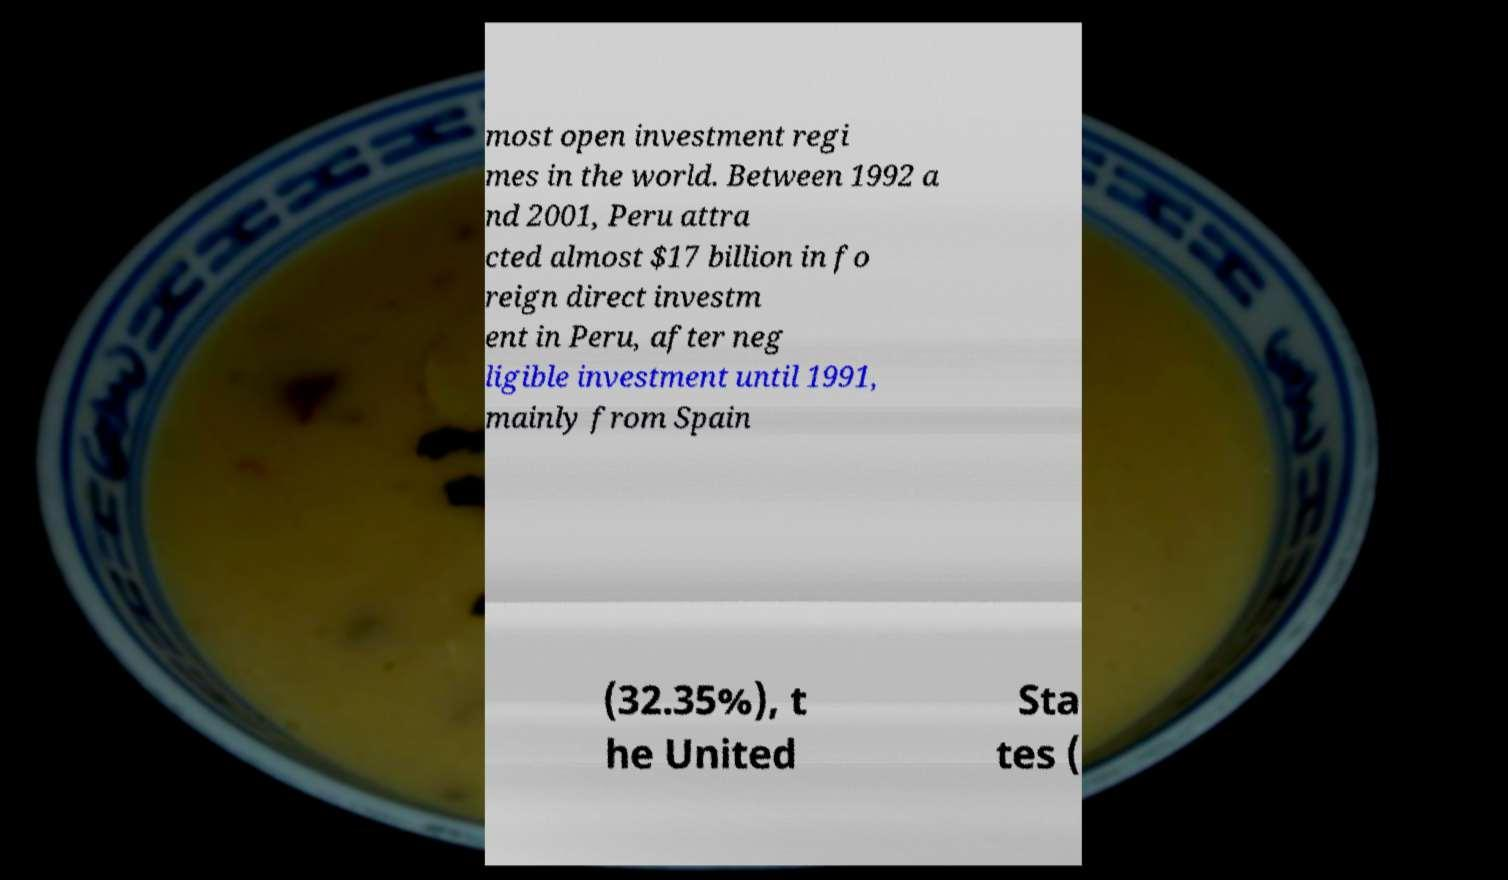Could you extract and type out the text from this image? most open investment regi mes in the world. Between 1992 a nd 2001, Peru attra cted almost $17 billion in fo reign direct investm ent in Peru, after neg ligible investment until 1991, mainly from Spain (32.35%), t he United Sta tes ( 